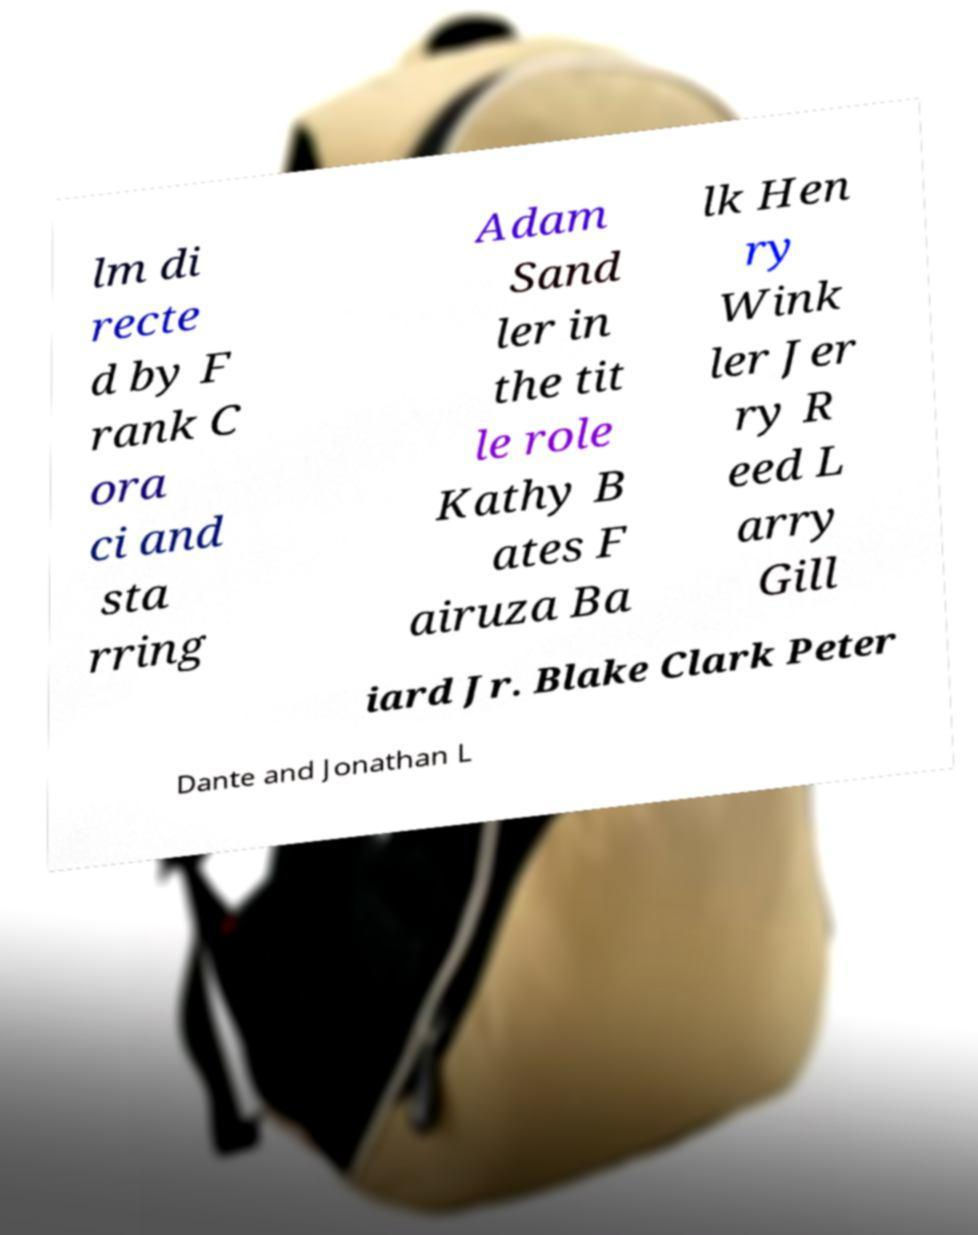I need the written content from this picture converted into text. Can you do that? lm di recte d by F rank C ora ci and sta rring Adam Sand ler in the tit le role Kathy B ates F airuza Ba lk Hen ry Wink ler Jer ry R eed L arry Gill iard Jr. Blake Clark Peter Dante and Jonathan L 